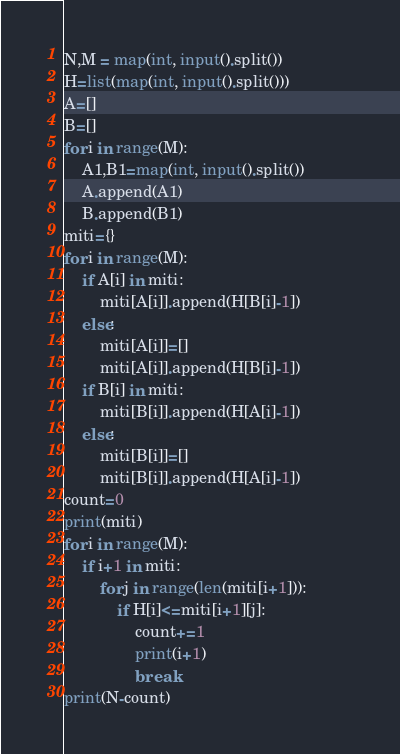Convert code to text. <code><loc_0><loc_0><loc_500><loc_500><_Python_>N,M = map(int, input().split())
H=list(map(int, input().split()))
A=[]
B=[]
for i in range(M):
    A1,B1=map(int, input().split())
    A.append(A1)
    B.append(B1)
miti={}
for i in range(M):
    if A[i] in miti:
        miti[A[i]].append(H[B[i]-1])            
    else:
        miti[A[i]]=[]
        miti[A[i]].append(H[B[i]-1])
    if B[i] in miti:
        miti[B[i]].append(H[A[i]-1])            
    else:
        miti[B[i]]=[]
        miti[B[i]].append(H[A[i]-1])
count=0
print(miti)
for i in range(M):
    if i+1 in miti:
        for j in range(len(miti[i+1])):
            if H[i]<=miti[i+1][j]:
                count+=1
                print(i+1)
                break
print(N-count)</code> 